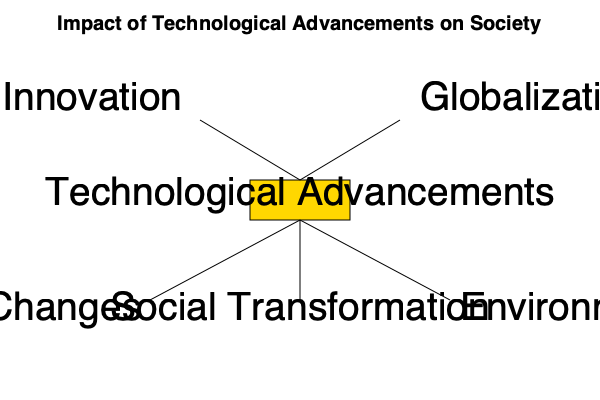As a historian examining the impact of technological advancements on society, which effect in the cause-and-effect diagram would likely be most relevant to your next book project on the industrial revolution's long-term consequences? To answer this question, let's analyze each effect shown in the cause-and-effect diagram and its relevance to the industrial revolution's long-term consequences:

1. Economic Changes:
   - The industrial revolution fundamentally transformed economic systems.
   - It led to the rise of factories, mass production, and new economic models.
   - This effect had far-reaching consequences on labor, wealth distribution, and global trade.

2. Social Transformation:
   - The industrial revolution altered social structures and living conditions.
   - It caused urbanization, changes in family dynamics, and the emergence of new social classes.
   - While significant, this effect is slightly less comprehensive than economic changes in the context of long-term consequences.

3. Environmental Impact:
   - Although important, the environmental impact of the industrial revolution was not as immediately apparent or widely discussed during its early stages.
   - This effect became more prominent in later discourse and might be considered a secondary consequence.

Considering the industrial revolution's primary focus on economic and productive transformations, the "Economic Changes" effect would likely be the most relevant and comprehensive topic for a historian's book project on its long-term consequences. This effect encompasses various aspects of societal change and provides a foundation for understanding other subsequent transformations.
Answer: Economic Changes 